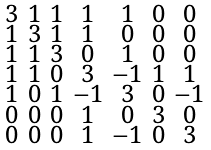<formula> <loc_0><loc_0><loc_500><loc_500>\begin{smallmatrix} 3 & 1 & 1 & 1 & 1 & 0 & 0 \\ 1 & 3 & 1 & 1 & 0 & 0 & 0 \\ 1 & 1 & 3 & 0 & 1 & 0 & 0 \\ 1 & 1 & 0 & 3 & - 1 & 1 & 1 \\ 1 & 0 & 1 & - 1 & 3 & 0 & - 1 \\ 0 & 0 & 0 & 1 & 0 & 3 & 0 \\ 0 & 0 & 0 & 1 & - 1 & 0 & 3 \end{smallmatrix}</formula> 